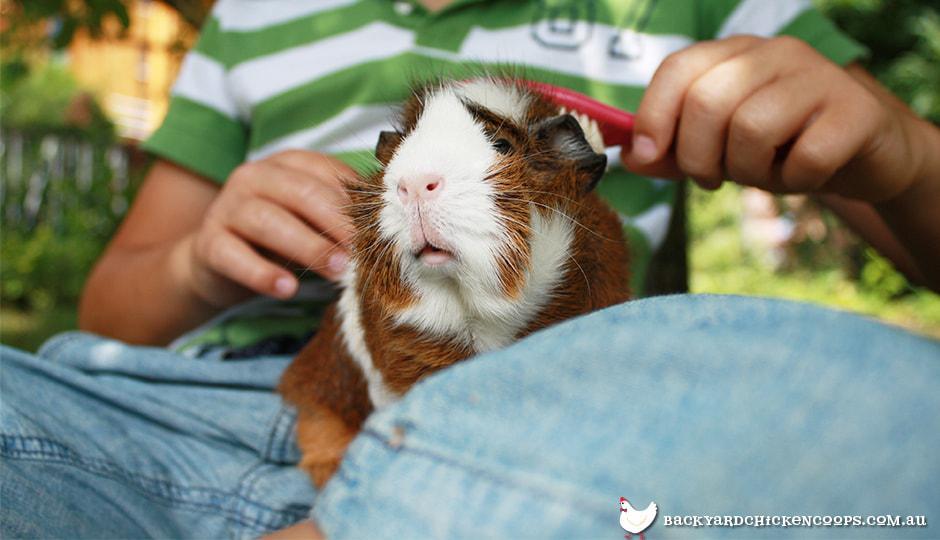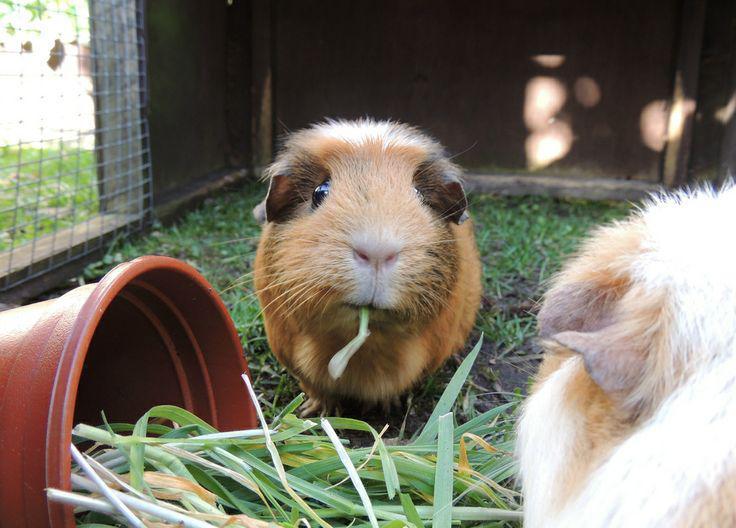The first image is the image on the left, the second image is the image on the right. Examine the images to the left and right. Is the description "There are at least six guinea pigs." accurate? Answer yes or no. No. The first image is the image on the left, the second image is the image on the right. Assess this claim about the two images: "There are no more than four guinea pigs". Correct or not? Answer yes or no. Yes. 